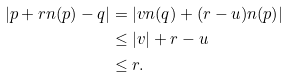<formula> <loc_0><loc_0><loc_500><loc_500>| p + r n ( p ) - q | & = | v n ( q ) + ( r - u ) n ( p ) | \\ & \leq | v | + r - u \\ & \leq r .</formula> 